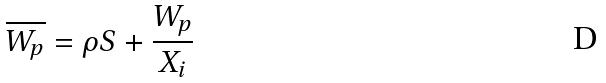<formula> <loc_0><loc_0><loc_500><loc_500>\overline { W _ { p } } = \rho S + \frac { W _ { p } } { X _ { i } }</formula> 